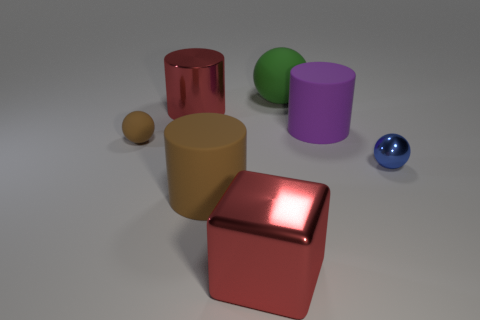Subtract 1 cylinders. How many cylinders are left? 2 Add 3 shiny things. How many objects exist? 10 Subtract all cubes. How many objects are left? 6 Subtract all purple shiny objects. Subtract all green objects. How many objects are left? 6 Add 7 rubber cylinders. How many rubber cylinders are left? 9 Add 1 metal cylinders. How many metal cylinders exist? 2 Subtract 0 purple cubes. How many objects are left? 7 